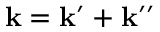<formula> <loc_0><loc_0><loc_500><loc_500>k = k ^ { \prime } + k ^ { \prime \prime }</formula> 